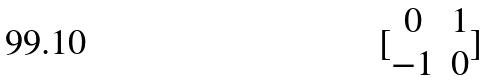Convert formula to latex. <formula><loc_0><loc_0><loc_500><loc_500>[ \begin{matrix} 0 & 1 \\ - 1 & 0 \end{matrix} ]</formula> 